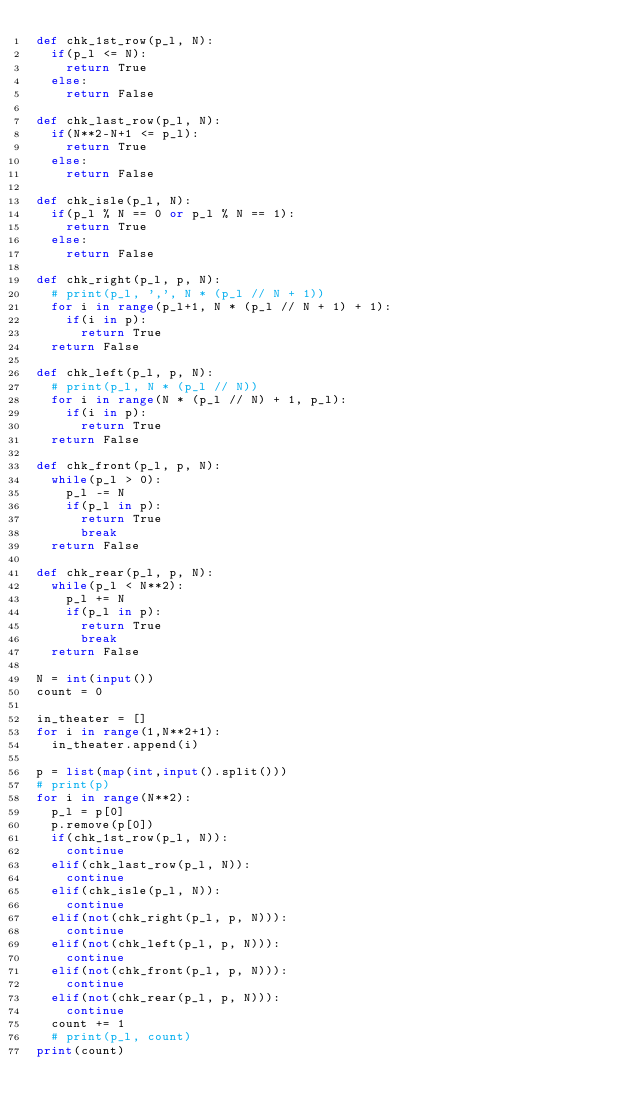Convert code to text. <code><loc_0><loc_0><loc_500><loc_500><_Python_>def chk_1st_row(p_l, N):
  if(p_l <= N):
    return True
  else:
    return False

def chk_last_row(p_l, N):
  if(N**2-N+1 <= p_l):
    return True
  else:
    return False
  
def chk_isle(p_l, N):
  if(p_l % N == 0 or p_l % N == 1):
    return True
  else:
    return False

def chk_right(p_l, p, N):
  # print(p_l, ',', N * (p_l // N + 1))
  for i in range(p_l+1, N * (p_l // N + 1) + 1):
    if(i in p):
      return True
  return False

def chk_left(p_l, p, N):
  # print(p_l, N * (p_l // N))
  for i in range(N * (p_l // N) + 1, p_l):
    if(i in p):
      return True
  return False

def chk_front(p_l, p, N):
  while(p_l > 0):
    p_l -= N
    if(p_l in p):
      return True
      break
  return False

def chk_rear(p_l, p, N):
  while(p_l < N**2):
    p_l += N
    if(p_l in p):
      return True
      break
  return False

N = int(input())
count = 0

in_theater = []
for i in range(1,N**2+1):
  in_theater.append(i)

p = list(map(int,input().split()))
# print(p)
for i in range(N**2):
  p_l = p[0]
  p.remove(p[0])
  if(chk_1st_row(p_l, N)):
    continue
  elif(chk_last_row(p_l, N)):
    continue
  elif(chk_isle(p_l, N)):
    continue
  elif(not(chk_right(p_l, p, N))):
    continue
  elif(not(chk_left(p_l, p, N))):
    continue
  elif(not(chk_front(p_l, p, N))):
    continue
  elif(not(chk_rear(p_l, p, N))):
    continue
  count += 1
  # print(p_l, count)
print(count)
  </code> 